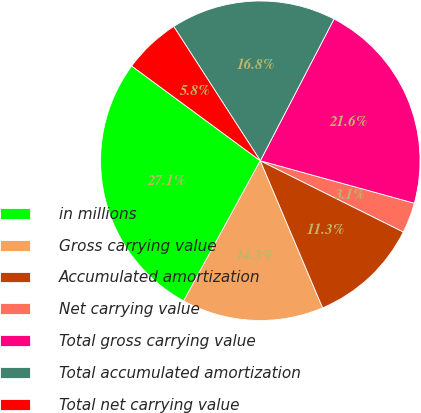<chart> <loc_0><loc_0><loc_500><loc_500><pie_chart><fcel>in millions<fcel>Gross carrying value<fcel>Accumulated amortization<fcel>Net carrying value<fcel>Total gross carrying value<fcel>Total accumulated amortization<fcel>Total net carrying value<nl><fcel>27.14%<fcel>14.34%<fcel>11.27%<fcel>3.07%<fcel>21.65%<fcel>16.75%<fcel>5.78%<nl></chart> 